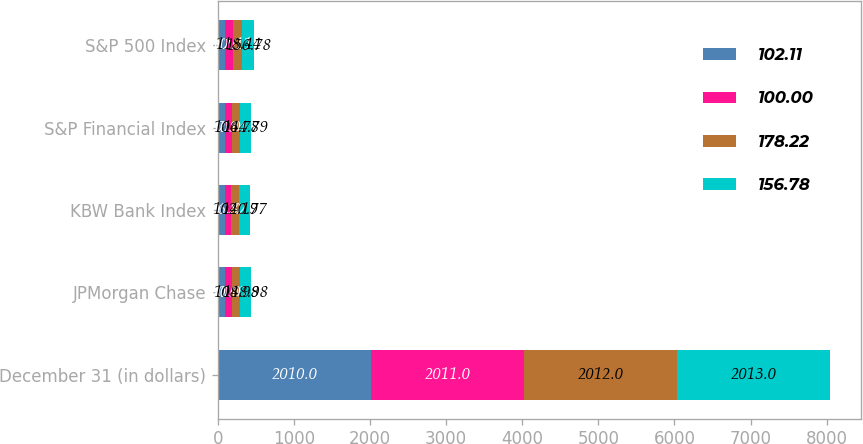<chart> <loc_0><loc_0><loc_500><loc_500><stacked_bar_chart><ecel><fcel>December 31 (in dollars)<fcel>JPMorgan Chase<fcel>KBW Bank Index<fcel>S&P Financial Index<fcel>S&P 500 Index<nl><fcel>102.11<fcel>2010<fcel>100<fcel>100<fcel>100<fcel>100<nl><fcel>100<fcel>2011<fcel>80.03<fcel>76.82<fcel>82.94<fcel>102.11<nl><fcel>178.22<fcel>2012<fcel>108.98<fcel>102.19<fcel>106.78<fcel>118.44<nl><fcel>156.78<fcel>2013<fcel>148.98<fcel>140.77<fcel>144.79<fcel>156.78<nl></chart> 